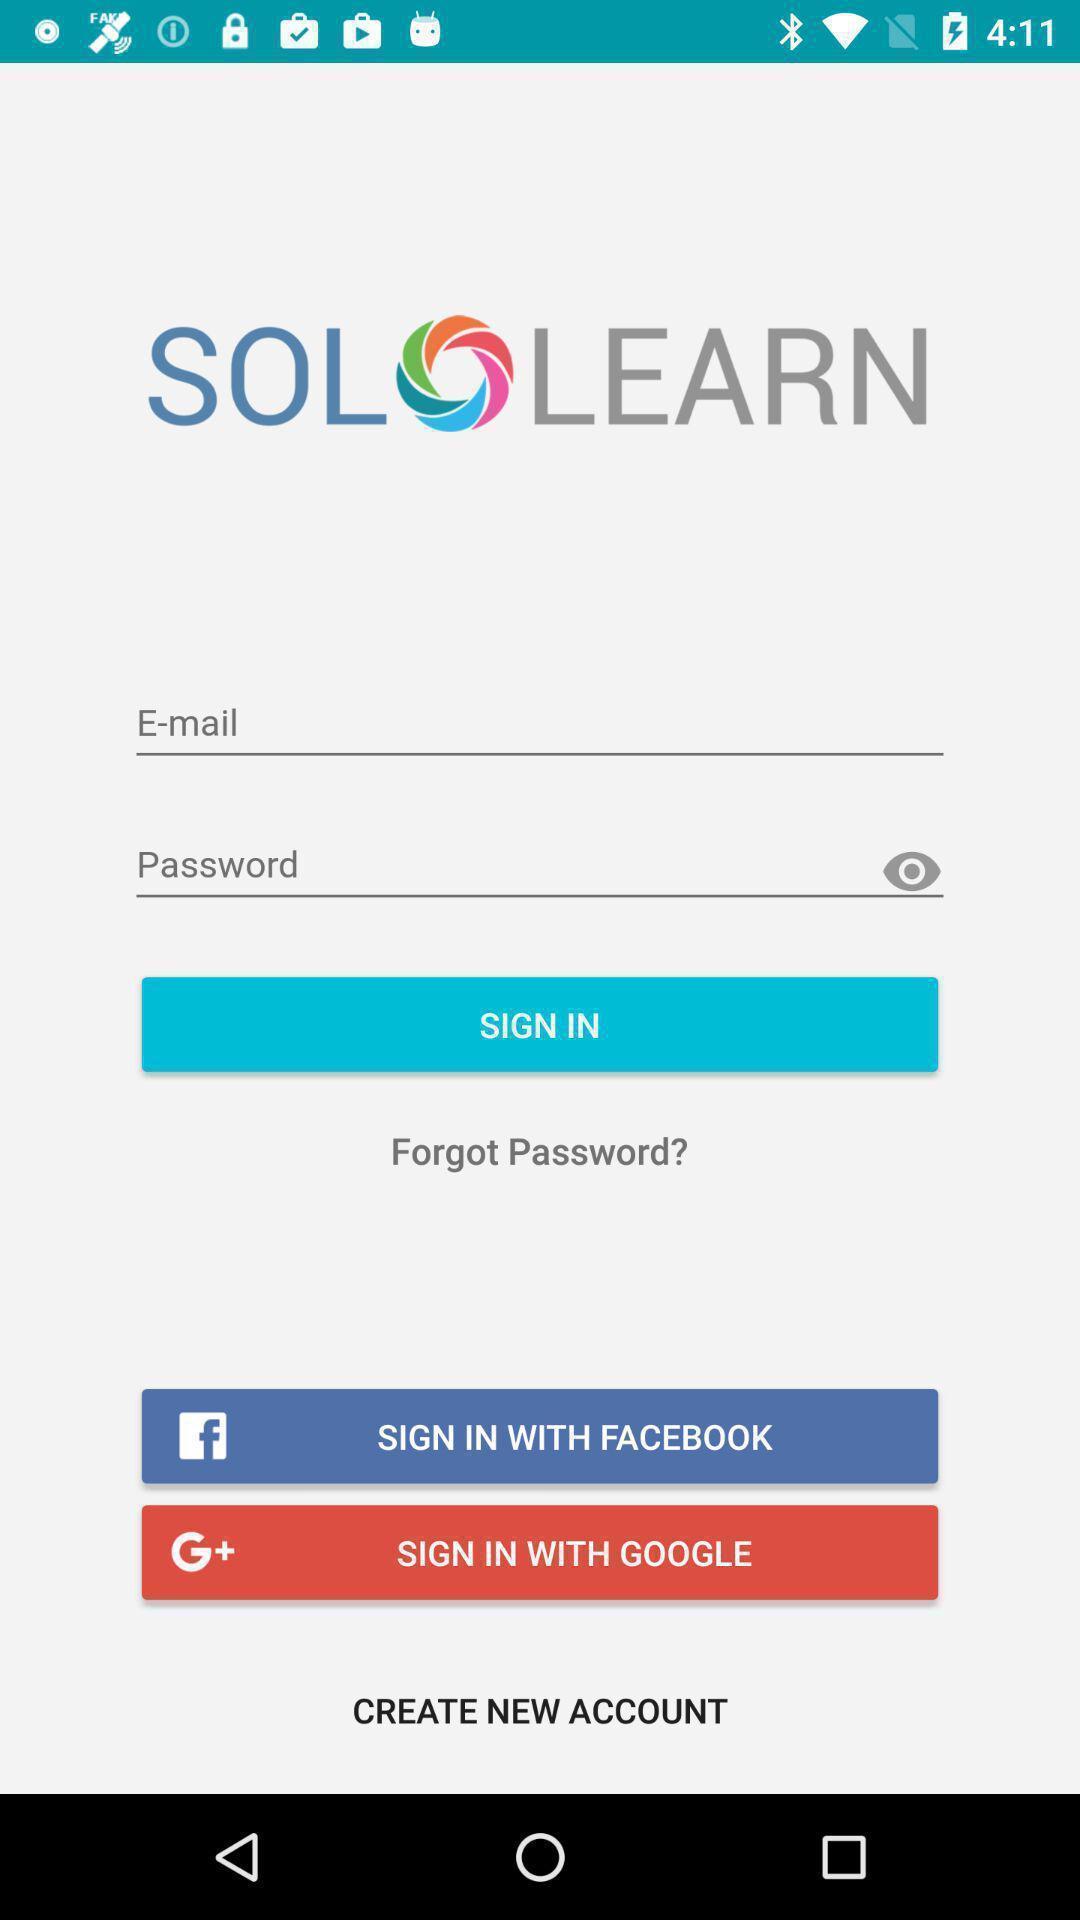Provide a textual representation of this image. Welcome and log-in page for an application. 